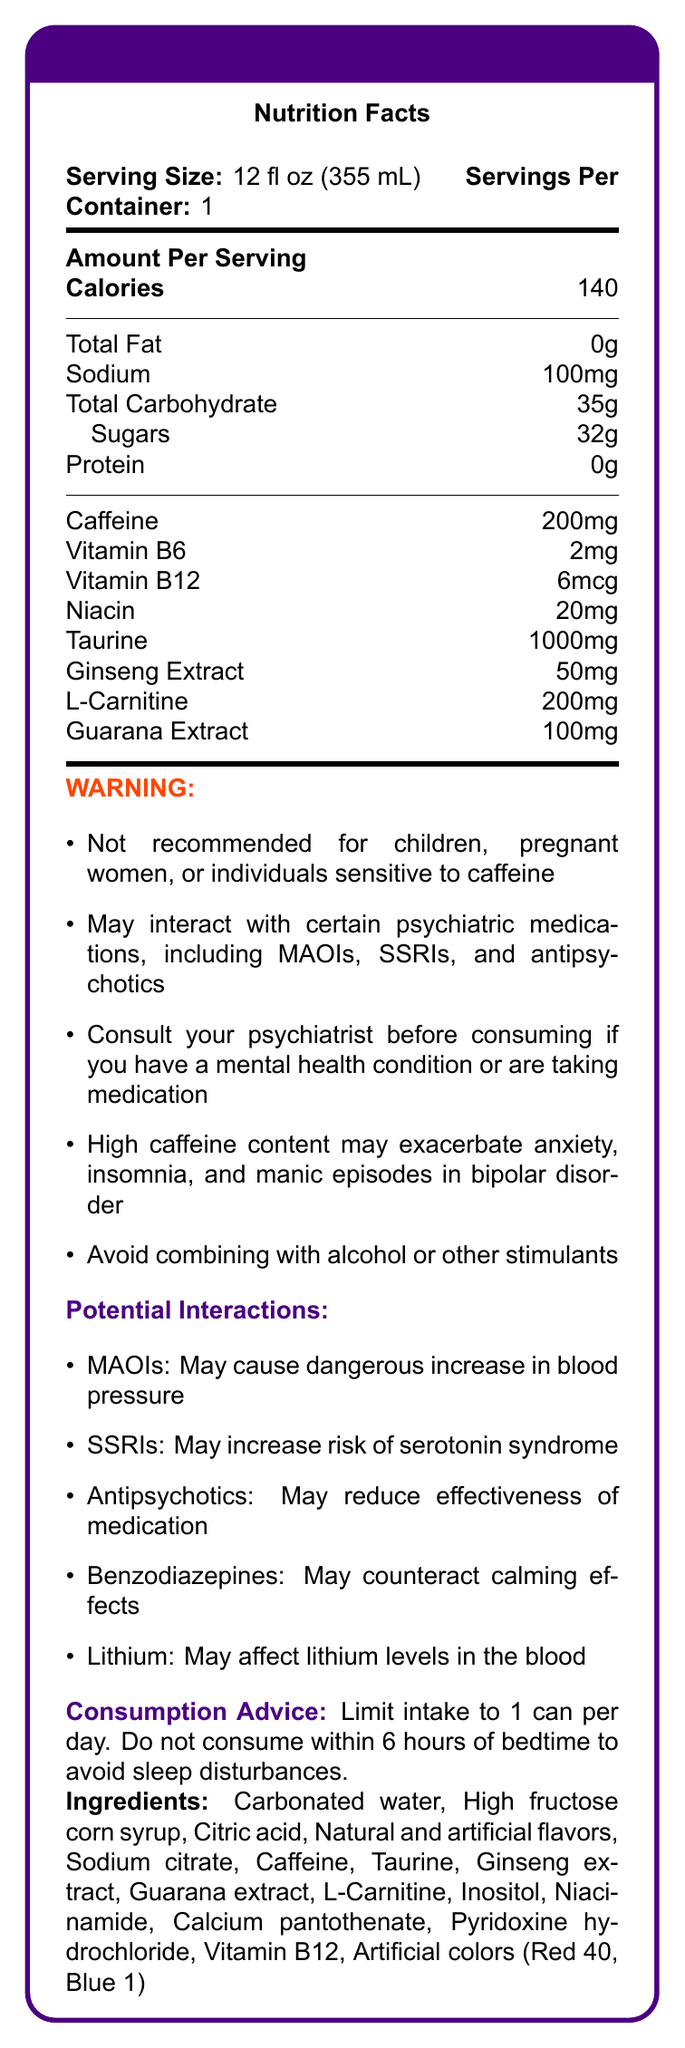What is the serving size of PsychoBoost Energy Drink? The serving size is listed at the beginning of the Nutrition Facts section.
Answer: 12 fl oz (355 mL) How many calories are in one serving of PsychoBoost Energy Drink? The calories are listed under the Amount Per Serving section.
Answer: 140 What is the amount of caffeine in one serving of the energy drink? The amount of caffeine is specified under the list of nutrient amounts.
Answer: 200mg Is there any protein in PsychoBoost Energy Drink? The protein content is listed as 0g in the nutritional information.
Answer: No How much sugar does the drink contain per serving? The sugar content is mentioned under Total Carbohydrate as 32g.
Answer: 32g Which psychiatric medications may interact with this energy drink? The document lists these medications under Potential Interactions.
Answer: MAOIs, SSRIs, antipsychotics, benzodiazepines, lithium What is the recommended intake limit for this energy drink? The consumption advice section recommends limiting intake to 1 can per day.
Answer: 1 can per day Which vitamin is present in the smallest amount in this energy drink? A. Vitamin B6 B. Vitamin B12 C. Niacin D. Vitamin C Vitamin B12 is present in the smallest amount, 6mcg.
Answer: B. Vitamin B12 What is one of the primary concerns of high caffeine content for someone with bipolar disorder? A. Increased energy B. Improved focus C. Exacerbated manic episodes D. Enhanced mood The warnings section states that high caffeine content may exacerbate manic episodes in bipolar disorder.
Answer: C. Exacerbated manic episodes Can PsychoBoost Energy Drink be consumed within 6 hours of bedtime? The consumption advice explicitly recommends not consuming within 6 hours of bedtime to avoid sleep disturbances.
Answer: No Summarize the entire document. The document provides comprehensive nutritional and safety information about PsychoBoost Energy Drink, emphasizing potential interactions with psychiatric treatments and special consumption advice.
Answer: The document is a Nutrition Facts Label for PsychoBoost Energy Drink. It provides nutritional information such as serving size, calories, and specific nutrients. It lists ingredients and includes several warnings regarding consumption, especially concerning interactions with psychiatric medications like MAOIs, SSRIs, and antipsychotics. There is advised consumption limit and timing, along with general notes on potential risks for individuals with mental health conditions. Can I consume this energy drink if I am on antipsychotic medication? The warnings section advises consultation with a psychiatrist if the person is taking psychiatric medication or has a mental health condition.
Answer: Consult your psychiatrist before consuming What will be the sodium intake from one can of this energy drink? The sodium content per serving is listed as 100mg.
Answer: 100mg Does the document mention any effects of this energy drink when combined with alcohol? The warnings section advises avoiding combining the energy drink with alcohol or other stimulants.
Answer: Yes What are the artificial colors used in PsychoBoost Energy Drink? The ingredients list specifies Red 40 and Blue 1 as the artificial colors used.
Answer: Red 40, Blue 1 Does this energy drink contain any fiber? There is no mention of dietary fiber in the nutritional information.
Answer: No How much taurine is in one serving of PsychoBoost Energy Drink? The amount of taurine is listed in the document under nutrient amounts.
Answer: 1000mg Can I determine the price of PsychoBoost Energy Drink from this document? The document does not provide any information regarding the price of the energy drink.
Answer: Cannot be determined 